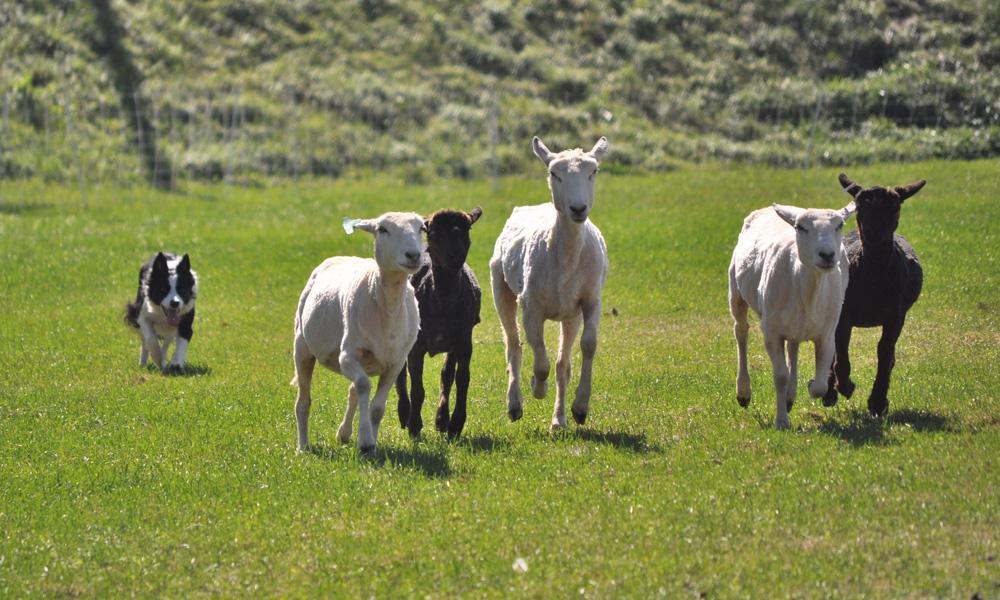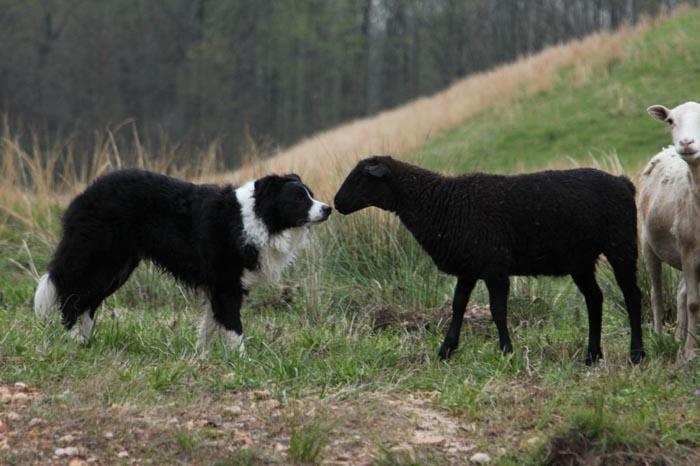The first image is the image on the left, the second image is the image on the right. Given the left and right images, does the statement "One image focuses on the dog close to one sheep." hold true? Answer yes or no. Yes. The first image is the image on the left, the second image is the image on the right. Examine the images to the left and right. Is the description "The dog in the image on the left is moving toward the camera." accurate? Answer yes or no. Yes. 